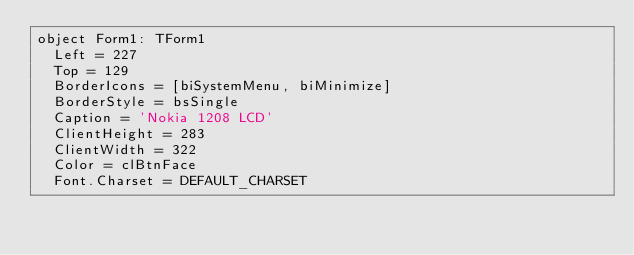<code> <loc_0><loc_0><loc_500><loc_500><_Pascal_>object Form1: TForm1
  Left = 227
  Top = 129
  BorderIcons = [biSystemMenu, biMinimize]
  BorderStyle = bsSingle
  Caption = 'Nokia 1208 LCD'
  ClientHeight = 283
  ClientWidth = 322
  Color = clBtnFace
  Font.Charset = DEFAULT_CHARSET</code> 